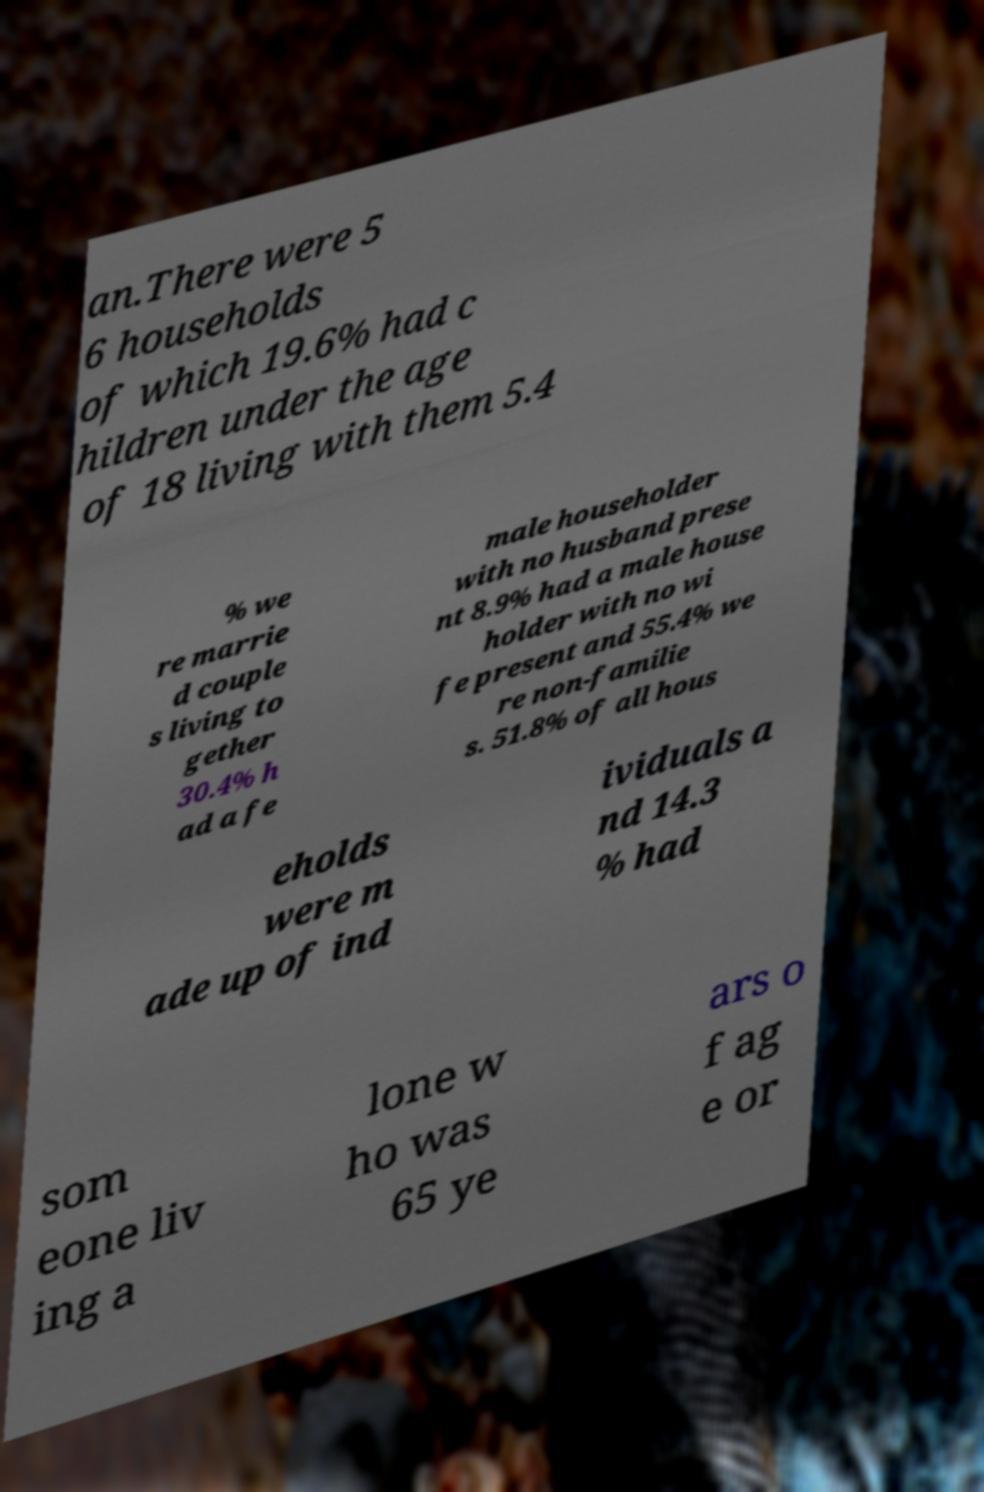Please identify and transcribe the text found in this image. an.There were 5 6 households of which 19.6% had c hildren under the age of 18 living with them 5.4 % we re marrie d couple s living to gether 30.4% h ad a fe male householder with no husband prese nt 8.9% had a male house holder with no wi fe present and 55.4% we re non-familie s. 51.8% of all hous eholds were m ade up of ind ividuals a nd 14.3 % had som eone liv ing a lone w ho was 65 ye ars o f ag e or 